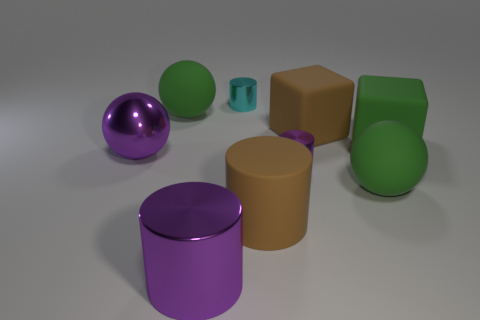How many green spheres must be subtracted to get 1 green spheres? 1 Add 1 large purple metal cubes. How many objects exist? 10 Subtract all balls. How many objects are left? 6 Add 4 cyan shiny things. How many cyan shiny things exist? 5 Subtract 0 cyan cubes. How many objects are left? 9 Subtract all large brown matte things. Subtract all cyan metal cylinders. How many objects are left? 6 Add 7 big rubber blocks. How many big rubber blocks are left? 9 